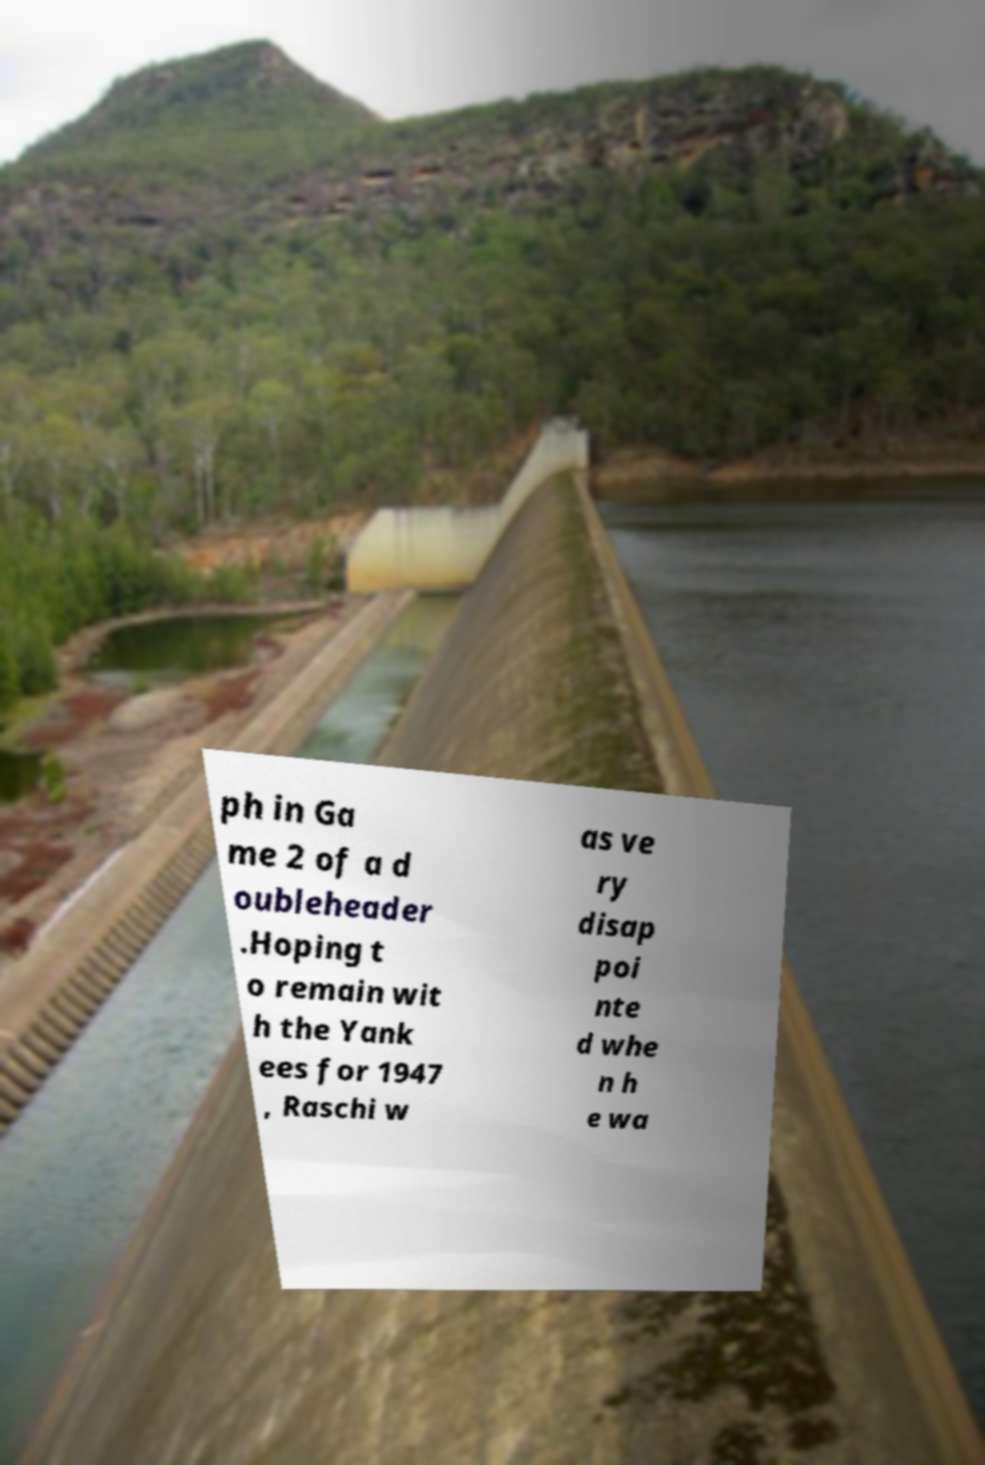Can you read and provide the text displayed in the image?This photo seems to have some interesting text. Can you extract and type it out for me? ph in Ga me 2 of a d oubleheader .Hoping t o remain wit h the Yank ees for 1947 , Raschi w as ve ry disap poi nte d whe n h e wa 